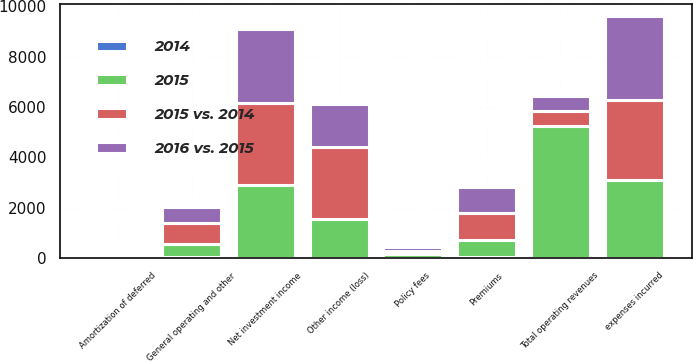<chart> <loc_0><loc_0><loc_500><loc_500><stacked_bar_chart><ecel><fcel>Premiums<fcel>Policy fees<fcel>Net investment income<fcel>Other income (loss)<fcel>Total operating revenues<fcel>expenses incurred<fcel>Amortization of deferred<fcel>General operating and other<nl><fcel>2015<fcel>674<fcel>142<fcel>2913<fcel>1521<fcel>5250<fcel>3084<fcel>108<fcel>524<nl><fcel>2016 vs. 2015<fcel>1037<fcel>133<fcel>2928<fcel>1673<fcel>588<fcel>3337<fcel>102<fcel>652<nl><fcel>2015 vs. 2014<fcel>1083<fcel>131<fcel>3245<fcel>2894<fcel>588<fcel>3197<fcel>81<fcel>837<nl><fcel>2014<fcel>35<fcel>7<fcel>1<fcel>9<fcel>9<fcel>8<fcel>6<fcel>20<nl></chart> 